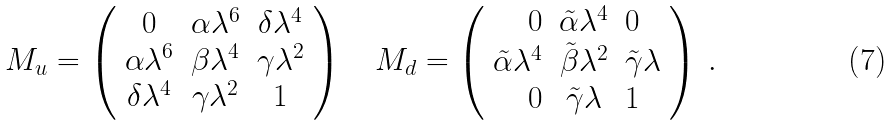Convert formula to latex. <formula><loc_0><loc_0><loc_500><loc_500>M _ { u } = \left ( \begin{array} { c c c } 0 & \alpha \lambda ^ { 6 } & \delta \lambda ^ { 4 } \\ \alpha \lambda ^ { 6 } & \beta \lambda ^ { 4 } & \gamma \lambda ^ { 2 } \\ \delta \lambda ^ { 4 } & \gamma \lambda ^ { 2 } & 1 \end{array} \right ) \quad M _ { d } = \left ( \begin{array} { r c l } 0 & { \tilde { \alpha } } \lambda ^ { 4 } & 0 \\ { \tilde { \alpha } } \lambda ^ { 4 } & { \tilde { \beta } } \lambda ^ { 2 } & { \tilde { \gamma } } \lambda \\ 0 & { \tilde { \gamma } } \lambda & 1 \end{array} \right ) \, .</formula> 